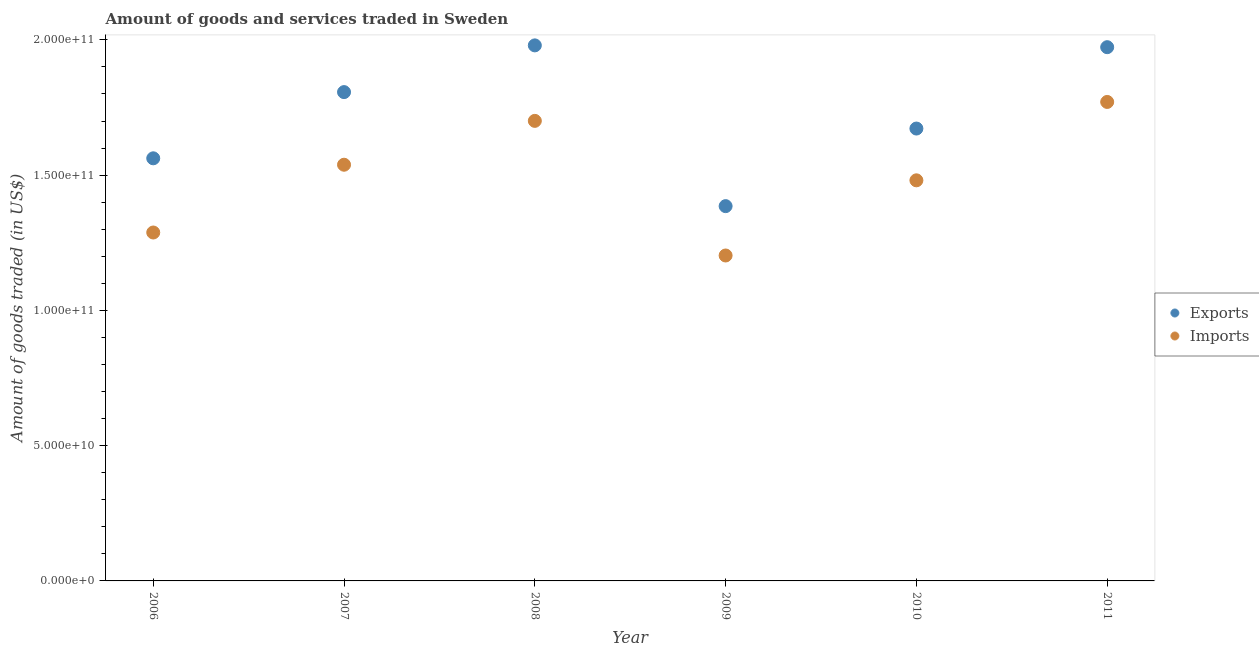What is the amount of goods exported in 2010?
Give a very brief answer. 1.67e+11. Across all years, what is the maximum amount of goods exported?
Your response must be concise. 1.98e+11. Across all years, what is the minimum amount of goods imported?
Give a very brief answer. 1.20e+11. What is the total amount of goods exported in the graph?
Your answer should be very brief. 1.04e+12. What is the difference between the amount of goods imported in 2009 and that in 2011?
Provide a succinct answer. -5.68e+1. What is the difference between the amount of goods exported in 2011 and the amount of goods imported in 2006?
Offer a very short reply. 6.85e+1. What is the average amount of goods imported per year?
Provide a succinct answer. 1.50e+11. In the year 2010, what is the difference between the amount of goods imported and amount of goods exported?
Give a very brief answer. -1.91e+1. In how many years, is the amount of goods exported greater than 110000000000 US$?
Ensure brevity in your answer.  6. What is the ratio of the amount of goods exported in 2006 to that in 2009?
Make the answer very short. 1.13. Is the amount of goods exported in 2007 less than that in 2010?
Keep it short and to the point. No. Is the difference between the amount of goods imported in 2006 and 2008 greater than the difference between the amount of goods exported in 2006 and 2008?
Provide a short and direct response. Yes. What is the difference between the highest and the second highest amount of goods exported?
Offer a terse response. 6.66e+08. What is the difference between the highest and the lowest amount of goods exported?
Give a very brief answer. 5.94e+1. In how many years, is the amount of goods exported greater than the average amount of goods exported taken over all years?
Your answer should be very brief. 3. Is the sum of the amount of goods imported in 2008 and 2010 greater than the maximum amount of goods exported across all years?
Your response must be concise. Yes. Does the amount of goods exported monotonically increase over the years?
Ensure brevity in your answer.  No. Is the amount of goods imported strictly less than the amount of goods exported over the years?
Offer a terse response. Yes. How many years are there in the graph?
Your answer should be compact. 6. Where does the legend appear in the graph?
Your answer should be very brief. Center right. What is the title of the graph?
Provide a short and direct response. Amount of goods and services traded in Sweden. Does "% of GNI" appear as one of the legend labels in the graph?
Offer a terse response. No. What is the label or title of the Y-axis?
Your answer should be very brief. Amount of goods traded (in US$). What is the Amount of goods traded (in US$) of Exports in 2006?
Provide a short and direct response. 1.56e+11. What is the Amount of goods traded (in US$) in Imports in 2006?
Your response must be concise. 1.29e+11. What is the Amount of goods traded (in US$) of Exports in 2007?
Provide a short and direct response. 1.81e+11. What is the Amount of goods traded (in US$) of Imports in 2007?
Provide a short and direct response. 1.54e+11. What is the Amount of goods traded (in US$) of Exports in 2008?
Provide a short and direct response. 1.98e+11. What is the Amount of goods traded (in US$) of Imports in 2008?
Keep it short and to the point. 1.70e+11. What is the Amount of goods traded (in US$) in Exports in 2009?
Ensure brevity in your answer.  1.39e+11. What is the Amount of goods traded (in US$) of Imports in 2009?
Ensure brevity in your answer.  1.20e+11. What is the Amount of goods traded (in US$) of Exports in 2010?
Ensure brevity in your answer.  1.67e+11. What is the Amount of goods traded (in US$) of Imports in 2010?
Give a very brief answer. 1.48e+11. What is the Amount of goods traded (in US$) in Exports in 2011?
Offer a very short reply. 1.97e+11. What is the Amount of goods traded (in US$) in Imports in 2011?
Offer a very short reply. 1.77e+11. Across all years, what is the maximum Amount of goods traded (in US$) in Exports?
Provide a succinct answer. 1.98e+11. Across all years, what is the maximum Amount of goods traded (in US$) in Imports?
Give a very brief answer. 1.77e+11. Across all years, what is the minimum Amount of goods traded (in US$) of Exports?
Your answer should be very brief. 1.39e+11. Across all years, what is the minimum Amount of goods traded (in US$) in Imports?
Provide a succinct answer. 1.20e+11. What is the total Amount of goods traded (in US$) of Exports in the graph?
Offer a terse response. 1.04e+12. What is the total Amount of goods traded (in US$) of Imports in the graph?
Keep it short and to the point. 8.98e+11. What is the difference between the Amount of goods traded (in US$) of Exports in 2006 and that in 2007?
Offer a terse response. -2.45e+1. What is the difference between the Amount of goods traded (in US$) in Imports in 2006 and that in 2007?
Offer a very short reply. -2.51e+1. What is the difference between the Amount of goods traded (in US$) in Exports in 2006 and that in 2008?
Your answer should be very brief. -4.17e+1. What is the difference between the Amount of goods traded (in US$) of Imports in 2006 and that in 2008?
Offer a terse response. -4.13e+1. What is the difference between the Amount of goods traded (in US$) of Exports in 2006 and that in 2009?
Ensure brevity in your answer.  1.77e+1. What is the difference between the Amount of goods traded (in US$) in Imports in 2006 and that in 2009?
Your response must be concise. 8.50e+09. What is the difference between the Amount of goods traded (in US$) in Exports in 2006 and that in 2010?
Give a very brief answer. -1.10e+1. What is the difference between the Amount of goods traded (in US$) of Imports in 2006 and that in 2010?
Offer a terse response. -1.93e+1. What is the difference between the Amount of goods traded (in US$) in Exports in 2006 and that in 2011?
Make the answer very short. -4.11e+1. What is the difference between the Amount of goods traded (in US$) in Imports in 2006 and that in 2011?
Make the answer very short. -4.83e+1. What is the difference between the Amount of goods traded (in US$) in Exports in 2007 and that in 2008?
Your answer should be very brief. -1.73e+1. What is the difference between the Amount of goods traded (in US$) of Imports in 2007 and that in 2008?
Ensure brevity in your answer.  -1.62e+1. What is the difference between the Amount of goods traded (in US$) of Exports in 2007 and that in 2009?
Your response must be concise. 4.22e+1. What is the difference between the Amount of goods traded (in US$) in Imports in 2007 and that in 2009?
Provide a succinct answer. 3.36e+1. What is the difference between the Amount of goods traded (in US$) in Exports in 2007 and that in 2010?
Your response must be concise. 1.35e+1. What is the difference between the Amount of goods traded (in US$) in Imports in 2007 and that in 2010?
Give a very brief answer. 5.76e+09. What is the difference between the Amount of goods traded (in US$) in Exports in 2007 and that in 2011?
Keep it short and to the point. -1.66e+1. What is the difference between the Amount of goods traded (in US$) of Imports in 2007 and that in 2011?
Offer a terse response. -2.32e+1. What is the difference between the Amount of goods traded (in US$) in Exports in 2008 and that in 2009?
Your answer should be compact. 5.94e+1. What is the difference between the Amount of goods traded (in US$) of Imports in 2008 and that in 2009?
Make the answer very short. 4.98e+1. What is the difference between the Amount of goods traded (in US$) in Exports in 2008 and that in 2010?
Ensure brevity in your answer.  3.07e+1. What is the difference between the Amount of goods traded (in US$) of Imports in 2008 and that in 2010?
Ensure brevity in your answer.  2.20e+1. What is the difference between the Amount of goods traded (in US$) of Exports in 2008 and that in 2011?
Your answer should be compact. 6.66e+08. What is the difference between the Amount of goods traded (in US$) of Imports in 2008 and that in 2011?
Ensure brevity in your answer.  -7.00e+09. What is the difference between the Amount of goods traded (in US$) of Exports in 2009 and that in 2010?
Provide a succinct answer. -2.87e+1. What is the difference between the Amount of goods traded (in US$) in Imports in 2009 and that in 2010?
Give a very brief answer. -2.78e+1. What is the difference between the Amount of goods traded (in US$) in Exports in 2009 and that in 2011?
Keep it short and to the point. -5.88e+1. What is the difference between the Amount of goods traded (in US$) of Imports in 2009 and that in 2011?
Your answer should be very brief. -5.68e+1. What is the difference between the Amount of goods traded (in US$) in Exports in 2010 and that in 2011?
Offer a very short reply. -3.01e+1. What is the difference between the Amount of goods traded (in US$) of Imports in 2010 and that in 2011?
Provide a short and direct response. -2.90e+1. What is the difference between the Amount of goods traded (in US$) of Exports in 2006 and the Amount of goods traded (in US$) of Imports in 2007?
Make the answer very short. 2.37e+09. What is the difference between the Amount of goods traded (in US$) of Exports in 2006 and the Amount of goods traded (in US$) of Imports in 2008?
Ensure brevity in your answer.  -1.38e+1. What is the difference between the Amount of goods traded (in US$) in Exports in 2006 and the Amount of goods traded (in US$) in Imports in 2009?
Make the answer very short. 3.59e+1. What is the difference between the Amount of goods traded (in US$) of Exports in 2006 and the Amount of goods traded (in US$) of Imports in 2010?
Your answer should be very brief. 8.14e+09. What is the difference between the Amount of goods traded (in US$) in Exports in 2006 and the Amount of goods traded (in US$) in Imports in 2011?
Your answer should be very brief. -2.08e+1. What is the difference between the Amount of goods traded (in US$) of Exports in 2007 and the Amount of goods traded (in US$) of Imports in 2008?
Make the answer very short. 1.06e+1. What is the difference between the Amount of goods traded (in US$) in Exports in 2007 and the Amount of goods traded (in US$) in Imports in 2009?
Make the answer very short. 6.04e+1. What is the difference between the Amount of goods traded (in US$) in Exports in 2007 and the Amount of goods traded (in US$) in Imports in 2010?
Offer a very short reply. 3.26e+1. What is the difference between the Amount of goods traded (in US$) in Exports in 2007 and the Amount of goods traded (in US$) in Imports in 2011?
Provide a short and direct response. 3.64e+09. What is the difference between the Amount of goods traded (in US$) of Exports in 2008 and the Amount of goods traded (in US$) of Imports in 2009?
Offer a terse response. 7.77e+1. What is the difference between the Amount of goods traded (in US$) of Exports in 2008 and the Amount of goods traded (in US$) of Imports in 2010?
Keep it short and to the point. 4.99e+1. What is the difference between the Amount of goods traded (in US$) of Exports in 2008 and the Amount of goods traded (in US$) of Imports in 2011?
Your answer should be compact. 2.09e+1. What is the difference between the Amount of goods traded (in US$) of Exports in 2009 and the Amount of goods traded (in US$) of Imports in 2010?
Give a very brief answer. -9.54e+09. What is the difference between the Amount of goods traded (in US$) in Exports in 2009 and the Amount of goods traded (in US$) in Imports in 2011?
Provide a succinct answer. -3.85e+1. What is the difference between the Amount of goods traded (in US$) in Exports in 2010 and the Amount of goods traded (in US$) in Imports in 2011?
Keep it short and to the point. -9.83e+09. What is the average Amount of goods traded (in US$) in Exports per year?
Your response must be concise. 1.73e+11. What is the average Amount of goods traded (in US$) in Imports per year?
Your answer should be compact. 1.50e+11. In the year 2006, what is the difference between the Amount of goods traded (in US$) in Exports and Amount of goods traded (in US$) in Imports?
Keep it short and to the point. 2.74e+1. In the year 2007, what is the difference between the Amount of goods traded (in US$) in Exports and Amount of goods traded (in US$) in Imports?
Your answer should be very brief. 2.68e+1. In the year 2008, what is the difference between the Amount of goods traded (in US$) in Exports and Amount of goods traded (in US$) in Imports?
Give a very brief answer. 2.79e+1. In the year 2009, what is the difference between the Amount of goods traded (in US$) in Exports and Amount of goods traded (in US$) in Imports?
Ensure brevity in your answer.  1.82e+1. In the year 2010, what is the difference between the Amount of goods traded (in US$) in Exports and Amount of goods traded (in US$) in Imports?
Your response must be concise. 1.91e+1. In the year 2011, what is the difference between the Amount of goods traded (in US$) of Exports and Amount of goods traded (in US$) of Imports?
Offer a very short reply. 2.02e+1. What is the ratio of the Amount of goods traded (in US$) of Exports in 2006 to that in 2007?
Keep it short and to the point. 0.86. What is the ratio of the Amount of goods traded (in US$) of Imports in 2006 to that in 2007?
Give a very brief answer. 0.84. What is the ratio of the Amount of goods traded (in US$) of Exports in 2006 to that in 2008?
Offer a very short reply. 0.79. What is the ratio of the Amount of goods traded (in US$) of Imports in 2006 to that in 2008?
Your response must be concise. 0.76. What is the ratio of the Amount of goods traded (in US$) of Exports in 2006 to that in 2009?
Your answer should be very brief. 1.13. What is the ratio of the Amount of goods traded (in US$) of Imports in 2006 to that in 2009?
Ensure brevity in your answer.  1.07. What is the ratio of the Amount of goods traded (in US$) in Exports in 2006 to that in 2010?
Provide a short and direct response. 0.93. What is the ratio of the Amount of goods traded (in US$) in Imports in 2006 to that in 2010?
Offer a very short reply. 0.87. What is the ratio of the Amount of goods traded (in US$) in Exports in 2006 to that in 2011?
Ensure brevity in your answer.  0.79. What is the ratio of the Amount of goods traded (in US$) in Imports in 2006 to that in 2011?
Give a very brief answer. 0.73. What is the ratio of the Amount of goods traded (in US$) in Exports in 2007 to that in 2008?
Offer a very short reply. 0.91. What is the ratio of the Amount of goods traded (in US$) in Imports in 2007 to that in 2008?
Provide a succinct answer. 0.9. What is the ratio of the Amount of goods traded (in US$) of Exports in 2007 to that in 2009?
Provide a short and direct response. 1.3. What is the ratio of the Amount of goods traded (in US$) of Imports in 2007 to that in 2009?
Provide a succinct answer. 1.28. What is the ratio of the Amount of goods traded (in US$) of Exports in 2007 to that in 2010?
Provide a short and direct response. 1.08. What is the ratio of the Amount of goods traded (in US$) of Imports in 2007 to that in 2010?
Make the answer very short. 1.04. What is the ratio of the Amount of goods traded (in US$) in Exports in 2007 to that in 2011?
Your answer should be very brief. 0.92. What is the ratio of the Amount of goods traded (in US$) in Imports in 2007 to that in 2011?
Offer a very short reply. 0.87. What is the ratio of the Amount of goods traded (in US$) in Exports in 2008 to that in 2009?
Provide a short and direct response. 1.43. What is the ratio of the Amount of goods traded (in US$) of Imports in 2008 to that in 2009?
Make the answer very short. 1.41. What is the ratio of the Amount of goods traded (in US$) in Exports in 2008 to that in 2010?
Provide a succinct answer. 1.18. What is the ratio of the Amount of goods traded (in US$) of Imports in 2008 to that in 2010?
Give a very brief answer. 1.15. What is the ratio of the Amount of goods traded (in US$) of Exports in 2008 to that in 2011?
Give a very brief answer. 1. What is the ratio of the Amount of goods traded (in US$) in Imports in 2008 to that in 2011?
Your answer should be very brief. 0.96. What is the ratio of the Amount of goods traded (in US$) of Exports in 2009 to that in 2010?
Make the answer very short. 0.83. What is the ratio of the Amount of goods traded (in US$) in Imports in 2009 to that in 2010?
Offer a very short reply. 0.81. What is the ratio of the Amount of goods traded (in US$) in Exports in 2009 to that in 2011?
Your answer should be compact. 0.7. What is the ratio of the Amount of goods traded (in US$) of Imports in 2009 to that in 2011?
Your answer should be compact. 0.68. What is the ratio of the Amount of goods traded (in US$) in Exports in 2010 to that in 2011?
Make the answer very short. 0.85. What is the ratio of the Amount of goods traded (in US$) of Imports in 2010 to that in 2011?
Provide a succinct answer. 0.84. What is the difference between the highest and the second highest Amount of goods traded (in US$) of Exports?
Provide a succinct answer. 6.66e+08. What is the difference between the highest and the second highest Amount of goods traded (in US$) in Imports?
Give a very brief answer. 7.00e+09. What is the difference between the highest and the lowest Amount of goods traded (in US$) of Exports?
Keep it short and to the point. 5.94e+1. What is the difference between the highest and the lowest Amount of goods traded (in US$) in Imports?
Keep it short and to the point. 5.68e+1. 